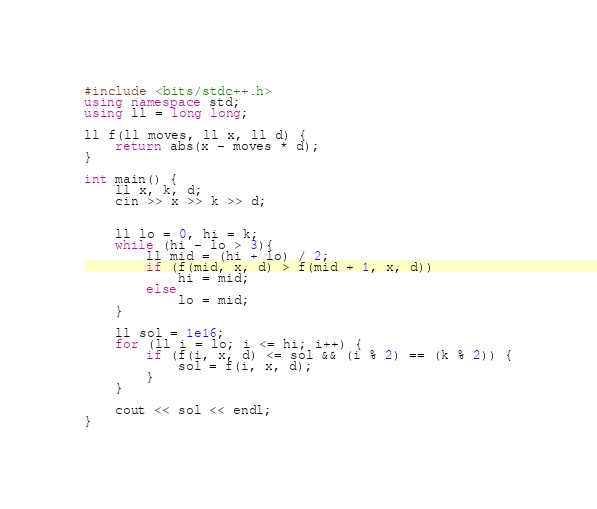<code> <loc_0><loc_0><loc_500><loc_500><_C++_>#include <bits/stdc++.h>
using namespace std;
using ll = long long;

ll f(ll moves, ll x, ll d) {
    return abs(x - moves * d);
}

int main() {
    ll x, k, d;
    cin >> x >> k >> d;


    ll lo = 0, hi = k;
    while (hi - lo > 3){
        ll mid = (hi + lo) / 2;
        if (f(mid, x, d) > f(mid + 1, x, d))
            hi = mid;
        else
            lo = mid;
    }

    ll sol = 1e16;
    for (ll i = lo; i <= hi; i++) {
        if (f(i, x, d) <= sol && (i % 2) == (k % 2)) {
            sol = f(i, x, d);
        }
    }

    cout << sol << endl;
}</code> 